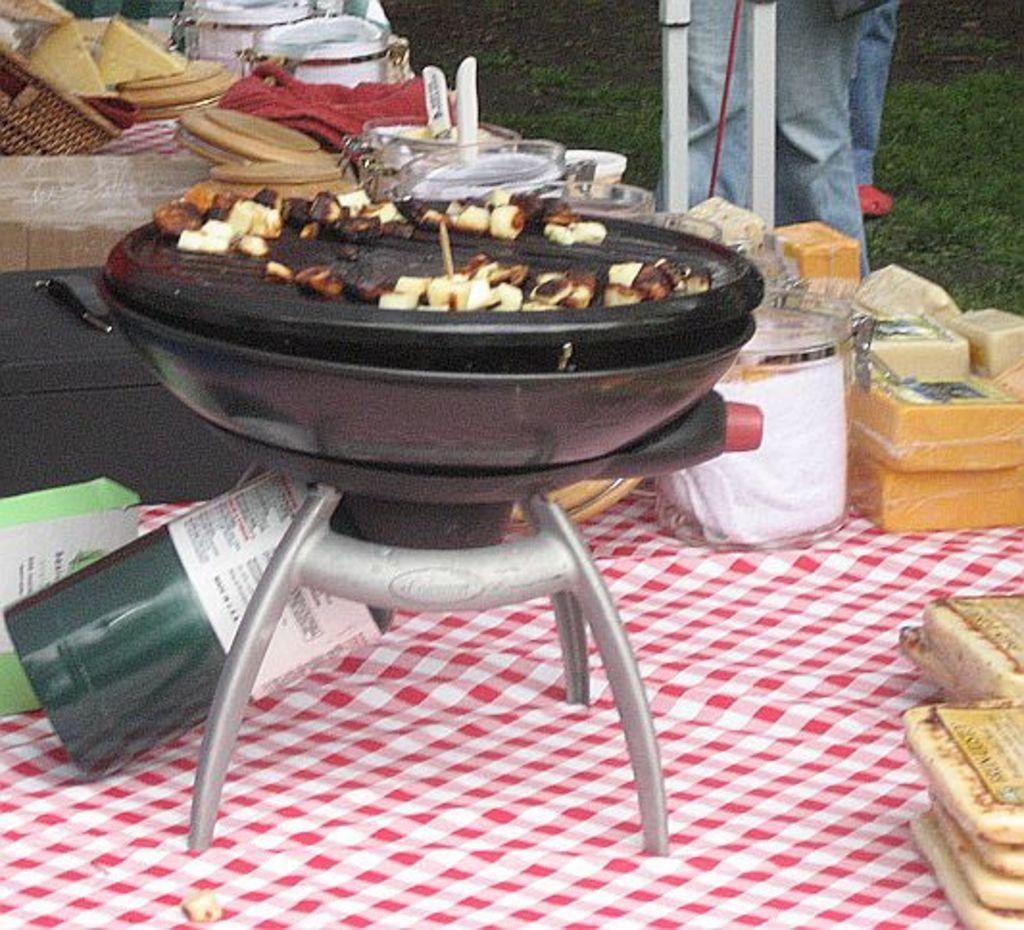Please provide a concise description of this image. In this image we can see a cloth on the ground and on the cloth there is a stove, some food items, a box and a few other objects, there are person legs and white color rod in the ground. 